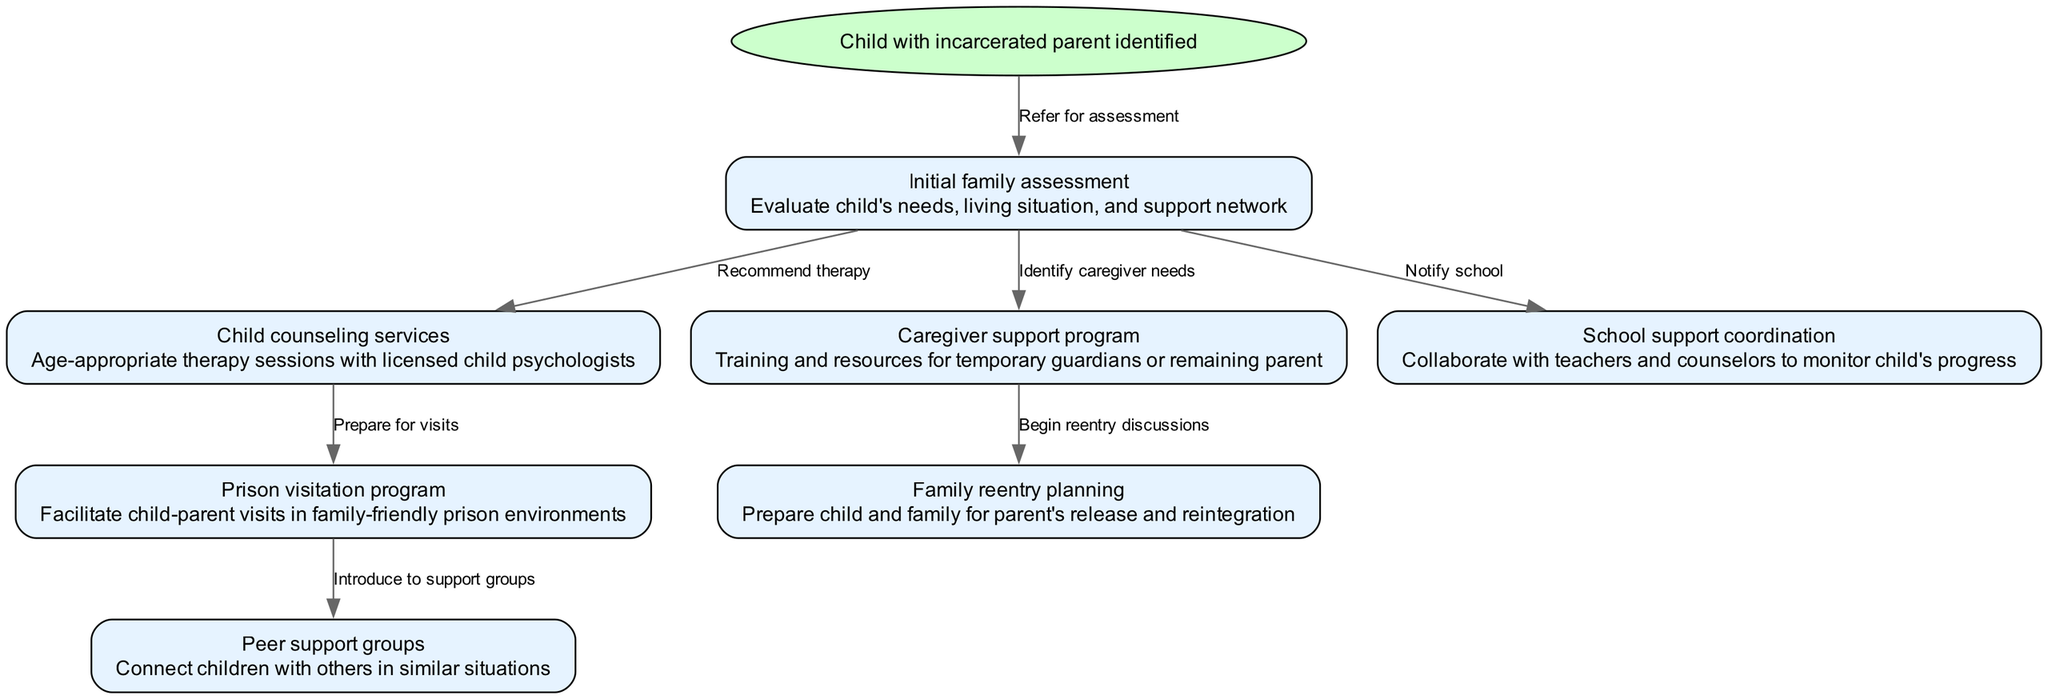What is the starting point of the pathway? The starting point of the pathway is clearly labeled as "Child with incarcerated parent identified." This indicates the initial situation that triggers the subsequent interventions.
Answer: Child with incarcerated parent identified What is the first intervention in the pathway? The diagram shows that after the start, the first intervention is the "Initial family assessment." It is directly connected from the starting point, indicating it is the first step taken.
Answer: Initial family assessment How many total interventions are listed in the pathway? To determine the total number of interventions, we can count the nodes that follow the starting point. There are seven nodes listed in the diagram under interventions.
Answer: Seven What intervention follows the Initial family assessment? The "Initial family assessment" leads to multiple interventions. The first one listed that follows it is "Child counseling services," as indicated by the directed edge connecting them.
Answer: Child counseling services What is the purpose of the caregiver support program? The caregiver support program aims to provide training and resources for temporary guardians or the remaining parent, as stated in the node details.
Answer: Training and resources for temporary guardians or remaining parent What are the two pathways that connect from the visitation program? The diagram shows that from the visitation program, there are two paths leading to "Peer support groups" and "Family reentry planning," indicating separate resources available after visitation.
Answer: Peer support groups and Family reentry planning Which intervention is connected to both Initial family assessment and caregiver support? The "Caregiver support program" is connected to the "Initial family assessment" through an identified need from the assessment. It also goes towards reentry planning, showing its significance in the support structure.
Answer: Caregiver support program How are children introduced to support groups? The introduction of children to support groups occurs through a connection from the visitation program. The diagram indicates that children who participate in visits are introduced to peer support groups afterward.
Answer: Introduced to peer support groups What does the family reentry planning involve? The family reentry planning involves preparing the child and family for the parent's release and reintegration, as outlined in the details of the "Family reentry planning" node.
Answer: Preparing the child and family for parent's release and reintegration 